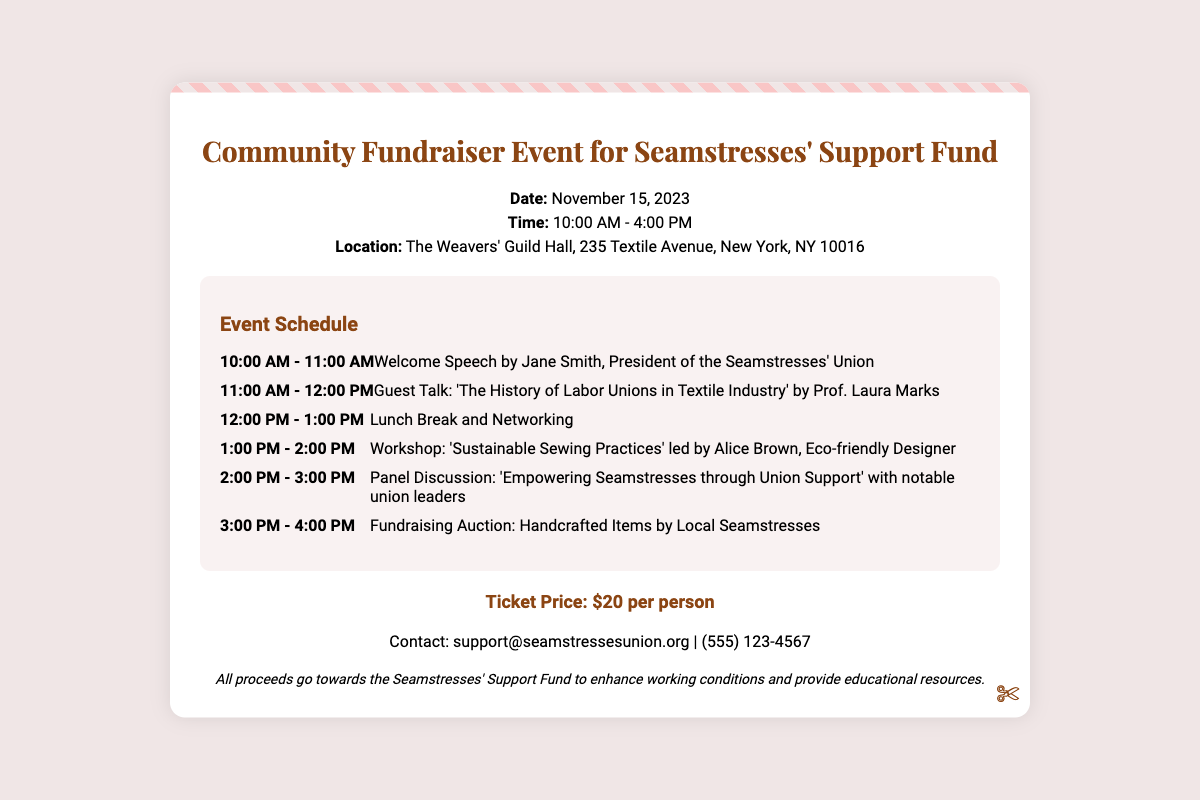What is the date of the event? The date of the event is mentioned in the event details section.
Answer: November 15, 2023 What time does the event start? The starting time is clearly stated in the event details.
Answer: 10:00 AM Where is the event taking place? The location is provided in the event details section.
Answer: The Weavers' Guild Hall, 235 Textile Avenue, New York, NY 10016 Who is giving the welcome speech? The name of the person giving the welcome speech is found in the event schedule.
Answer: Jane Smith What is the cost of the ticket? The ticket price is listed prominently in the document.
Answer: $20 per person What type of activities are included in the event? The document outlines the schedule with various activities planned throughout the day.
Answer: Workshops, Guest Talks, Panel Discussions, Fundraising Auction How long is the lunch break? The schedule lists a specific time frame for lunch and networking.
Answer: 1 hour What is the purpose of the fundraiser? The note section explains the purpose of the fundraiser clearly.
Answer: Enhance working conditions and provide educational resources 